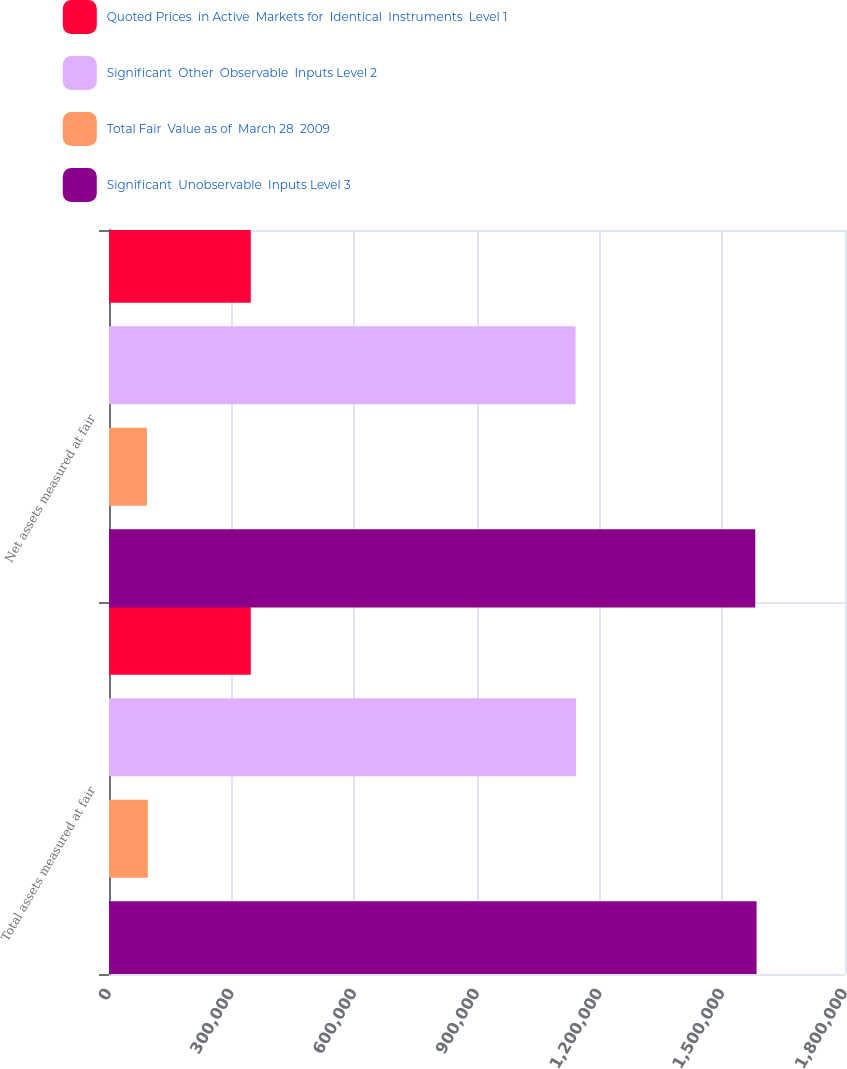<chart> <loc_0><loc_0><loc_500><loc_500><stacked_bar_chart><ecel><fcel>Total assets measured at fair<fcel>Net assets measured at fair<nl><fcel>Quoted Prices  in Active  Markets for  Identical  Instruments  Level 1<fcel>346722<fcel>346722<nl><fcel>Significant  Other  Observable  Inputs Level 2<fcel>1.14216e+06<fcel>1.14108e+06<nl><fcel>Total Fair  Value as of  March 28  2009<fcel>94846<fcel>92736<nl><fcel>Significant  Unobservable  Inputs Level 3<fcel>1.58373e+06<fcel>1.58054e+06<nl></chart> 